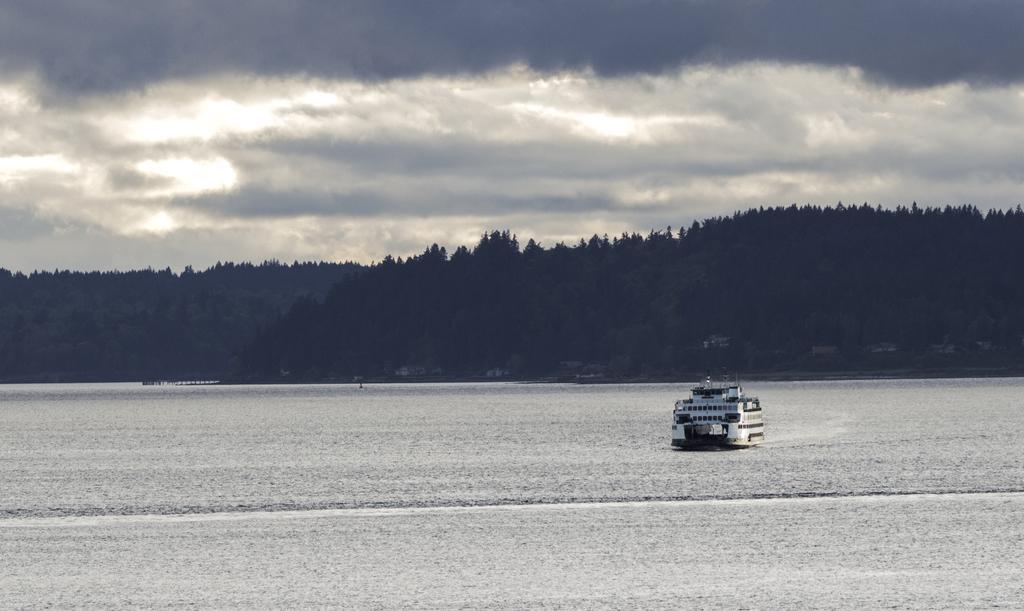Please provide a concise description of this image. This picture shows a cloudy sky and we see trees and a ship in the water. 